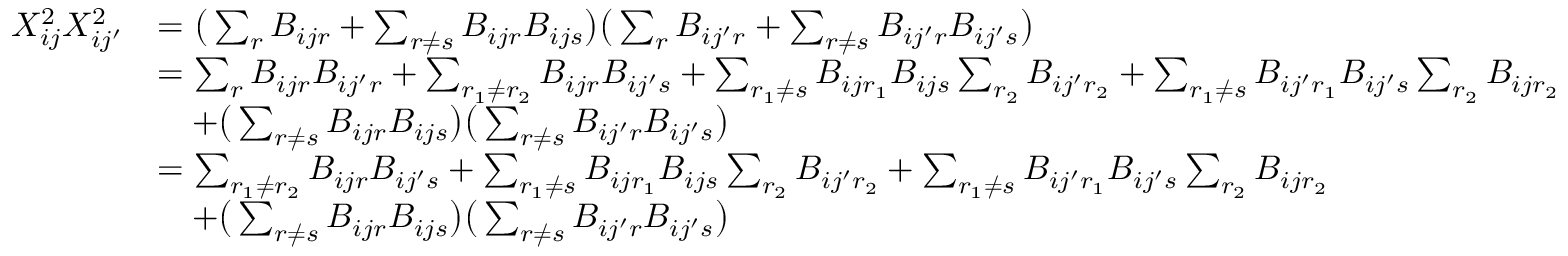Convert formula to latex. <formula><loc_0><loc_0><loc_500><loc_500>\begin{array} { r l } { X _ { i j } ^ { 2 } X _ { i j ^ { \prime } } ^ { 2 } } & { = \left ( \sum _ { r } B _ { i j r } + \sum _ { r \neq s } B _ { i j r } B _ { i j s } \right ) \left ( \sum _ { r } B _ { i j ^ { \prime } r } + \sum _ { r \neq s } B _ { i j ^ { \prime } r } B _ { i j ^ { \prime } s } \right ) } \\ & { = \sum _ { r } B _ { i j r } B _ { i j ^ { \prime } r } + \sum _ { r _ { 1 } \neq r _ { 2 } } B _ { i j r } B _ { i j ^ { \prime } s } + \sum _ { r _ { 1 } \neq s } B _ { i j r _ { 1 } } B _ { i j s } \sum _ { r _ { 2 } } B _ { i j ^ { \prime } r _ { 2 } } + \sum _ { r _ { 1 } \neq s } B _ { i j ^ { \prime } r _ { 1 } } B _ { i j ^ { \prime } s } \sum _ { r _ { 2 } } B _ { i j r _ { 2 } } } \\ & { \quad + \left ( \sum _ { r \neq s } B _ { i j r } B _ { i j s } \right ) \left ( \sum _ { r \neq s } B _ { i j ^ { \prime } r } B _ { i j ^ { \prime } s } \right ) } \\ & { = \sum _ { r _ { 1 } \neq r _ { 2 } } B _ { i j r } B _ { i j ^ { \prime } s } + \sum _ { r _ { 1 } \neq s } B _ { i j r _ { 1 } } B _ { i j s } \sum _ { r _ { 2 } } B _ { i j ^ { \prime } r _ { 2 } } + \sum _ { r _ { 1 } \neq s } B _ { i j ^ { \prime } r _ { 1 } } B _ { i j ^ { \prime } s } \sum _ { r _ { 2 } } B _ { i j r _ { 2 } } } \\ & { \quad + \left ( \sum _ { r \neq s } B _ { i j r } B _ { i j s } \right ) \left ( \sum _ { r \neq s } B _ { i j ^ { \prime } r } B _ { i j ^ { \prime } s } \right ) } \end{array}</formula> 